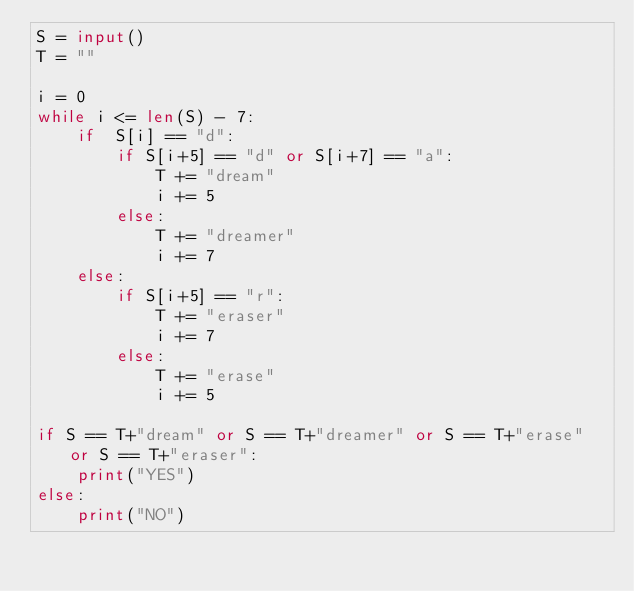Convert code to text. <code><loc_0><loc_0><loc_500><loc_500><_Python_>S = input()
T = ""

i = 0
while i <= len(S) - 7:
    if  S[i] == "d":
        if S[i+5] == "d" or S[i+7] == "a":
            T += "dream"
            i += 5
        else:
            T += "dreamer"
            i += 7
    else:
        if S[i+5] == "r":
            T += "eraser"
            i += 7
        else:
            T += "erase"
            i += 5

if S == T+"dream" or S == T+"dreamer" or S == T+"erase" or S == T+"eraser":
    print("YES")
else:
    print("NO")</code> 